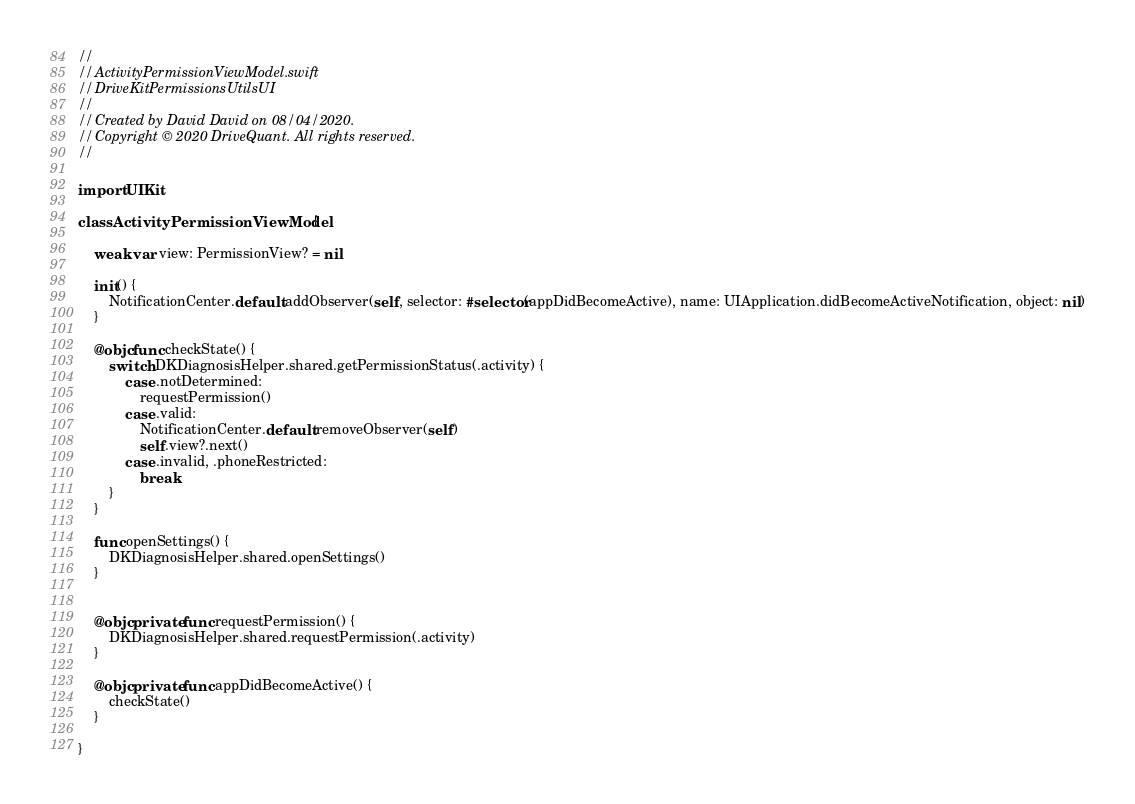Convert code to text. <code><loc_0><loc_0><loc_500><loc_500><_Swift_>//
//  ActivityPermissionViewModel.swift
//  DriveKitPermissionsUtilsUI
//
//  Created by David David on 08/04/2020.
//  Copyright © 2020 DriveQuant. All rights reserved.
//

import UIKit

class ActivityPermissionViewModel {

    weak var view: PermissionView? = nil

    init() {
        NotificationCenter.default.addObserver(self, selector: #selector(appDidBecomeActive), name: UIApplication.didBecomeActiveNotification, object: nil)
    }

    @objc func checkState() {
        switch DKDiagnosisHelper.shared.getPermissionStatus(.activity) {
            case .notDetermined:
                requestPermission()
            case .valid:
                NotificationCenter.default.removeObserver(self)
                self.view?.next()
            case .invalid, .phoneRestricted:
                break
        }
    }

    func openSettings() {
        DKDiagnosisHelper.shared.openSettings()
    }


    @objc private func requestPermission() {
        DKDiagnosisHelper.shared.requestPermission(.activity)
    }

    @objc private func appDidBecomeActive() {
        checkState()
    }

}
</code> 